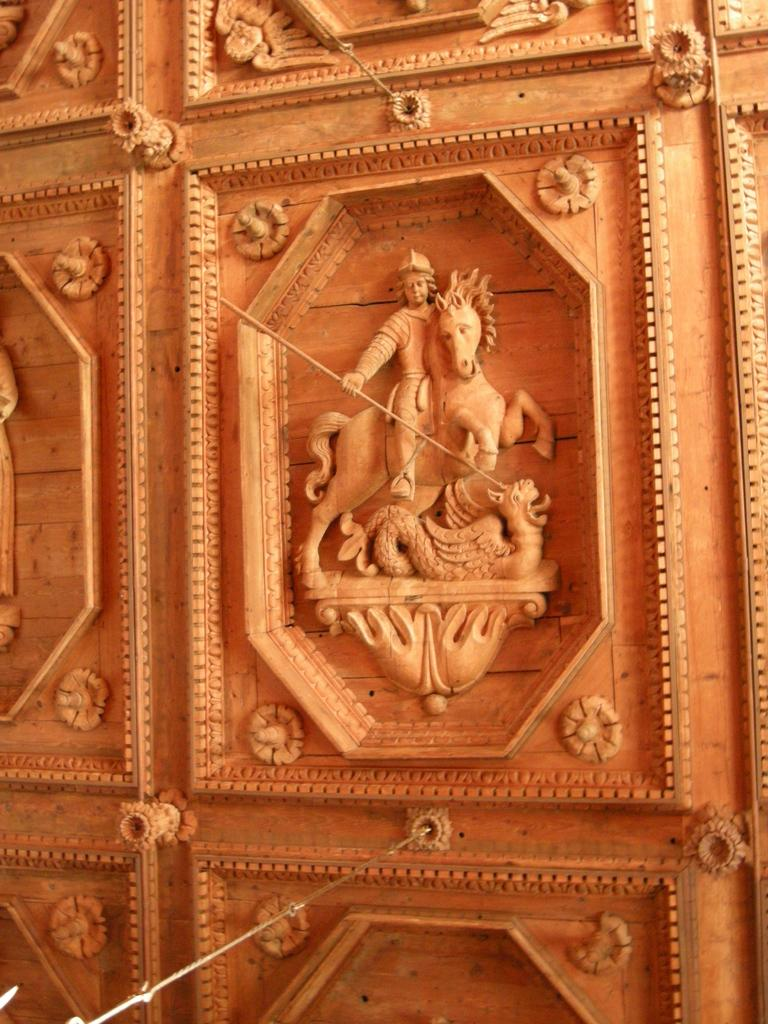What type of door is featured in the image? There is a carved wooden door in the image. Can you describe the material of the door? The door is made of wood, and it has been carved. What is the price of the cast in the image? There is no cast present in the image, and therefore no price can be determined. 